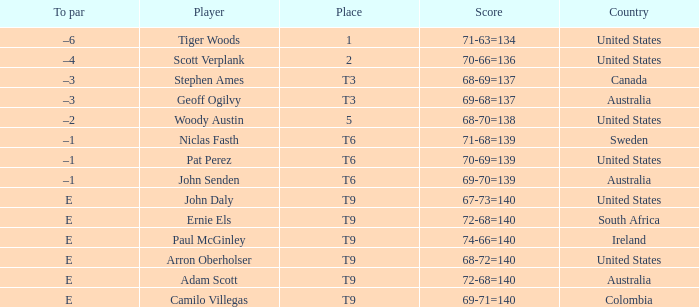Which country has a score of 70-66=136? United States. 